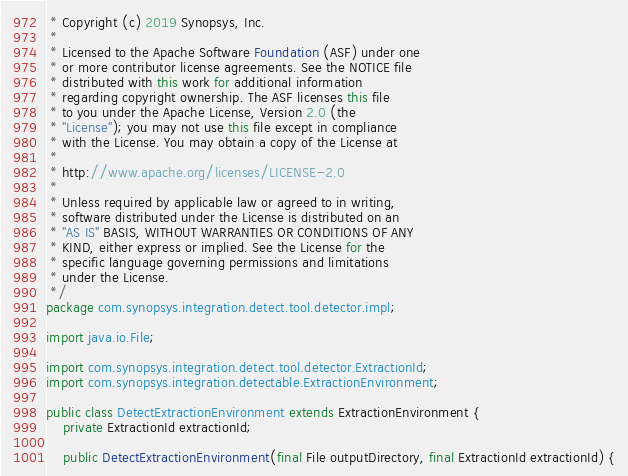Convert code to text. <code><loc_0><loc_0><loc_500><loc_500><_Java_> * Copyright (c) 2019 Synopsys, Inc.
 *
 * Licensed to the Apache Software Foundation (ASF) under one
 * or more contributor license agreements. See the NOTICE file
 * distributed with this work for additional information
 * regarding copyright ownership. The ASF licenses this file
 * to you under the Apache License, Version 2.0 (the
 * "License"); you may not use this file except in compliance
 * with the License. You may obtain a copy of the License at
 *
 * http://www.apache.org/licenses/LICENSE-2.0
 *
 * Unless required by applicable law or agreed to in writing,
 * software distributed under the License is distributed on an
 * "AS IS" BASIS, WITHOUT WARRANTIES OR CONDITIONS OF ANY
 * KIND, either express or implied. See the License for the
 * specific language governing permissions and limitations
 * under the License.
 */
package com.synopsys.integration.detect.tool.detector.impl;

import java.io.File;

import com.synopsys.integration.detect.tool.detector.ExtractionId;
import com.synopsys.integration.detectable.ExtractionEnvironment;

public class DetectExtractionEnvironment extends ExtractionEnvironment {
    private ExtractionId extractionId;

    public DetectExtractionEnvironment(final File outputDirectory, final ExtractionId extractionId) {</code> 